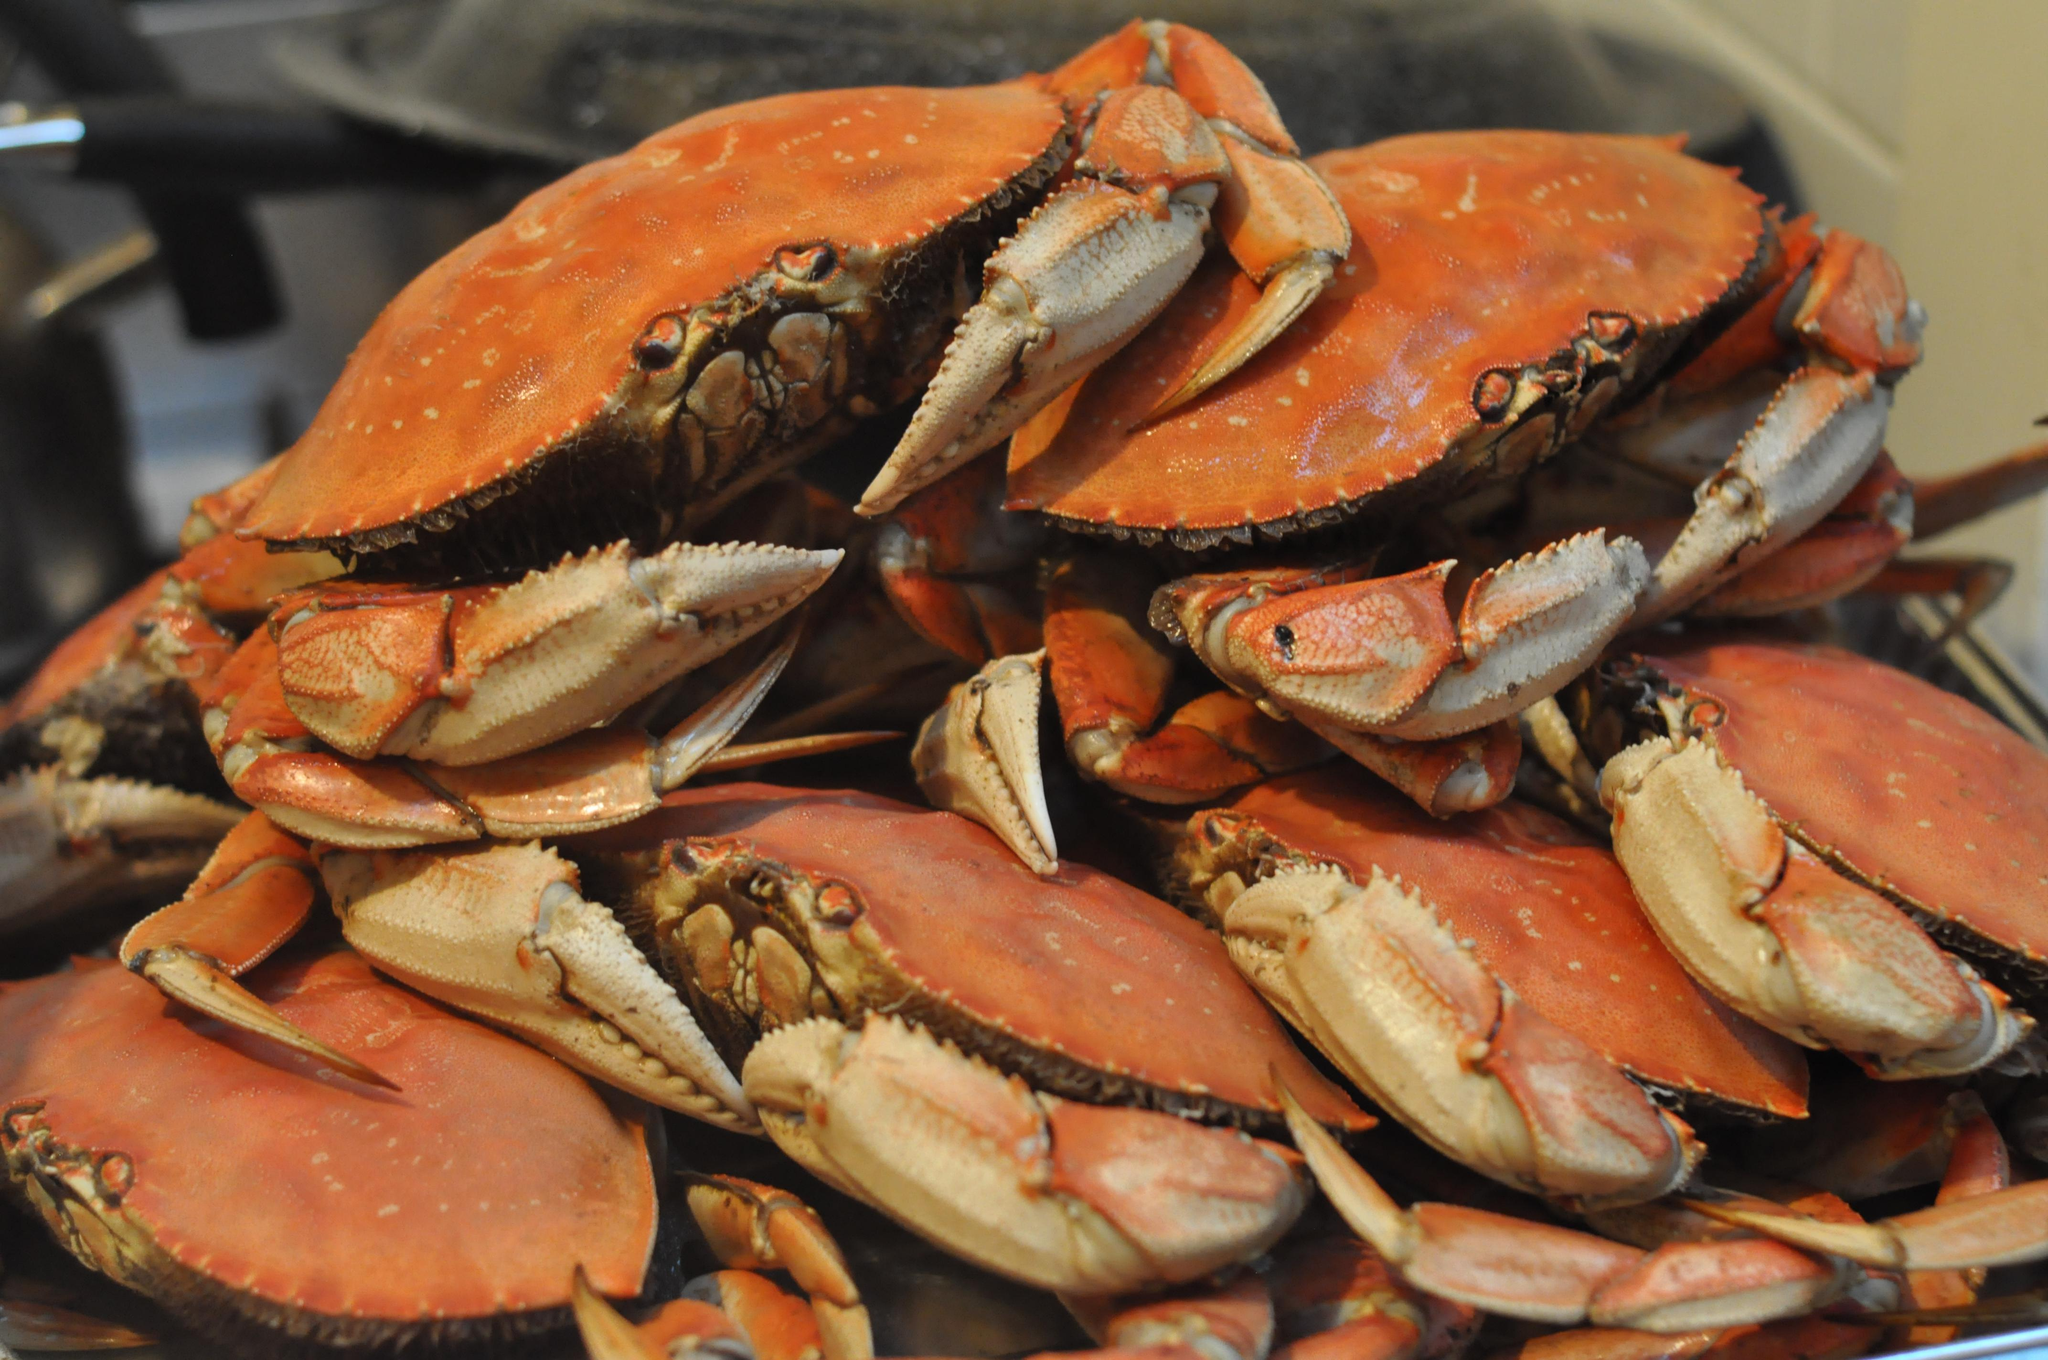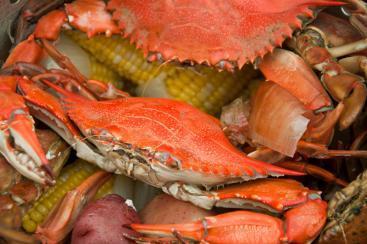The first image is the image on the left, the second image is the image on the right. Considering the images on both sides, is "The image on the right shows red crabs on top of vegetables including corn." valid? Answer yes or no. Yes. The first image is the image on the left, the second image is the image on the right. Examine the images to the left and right. Is the description "In one image, a person's hand can be seen holding a single large crab with its legs curled in front." accurate? Answer yes or no. No. 